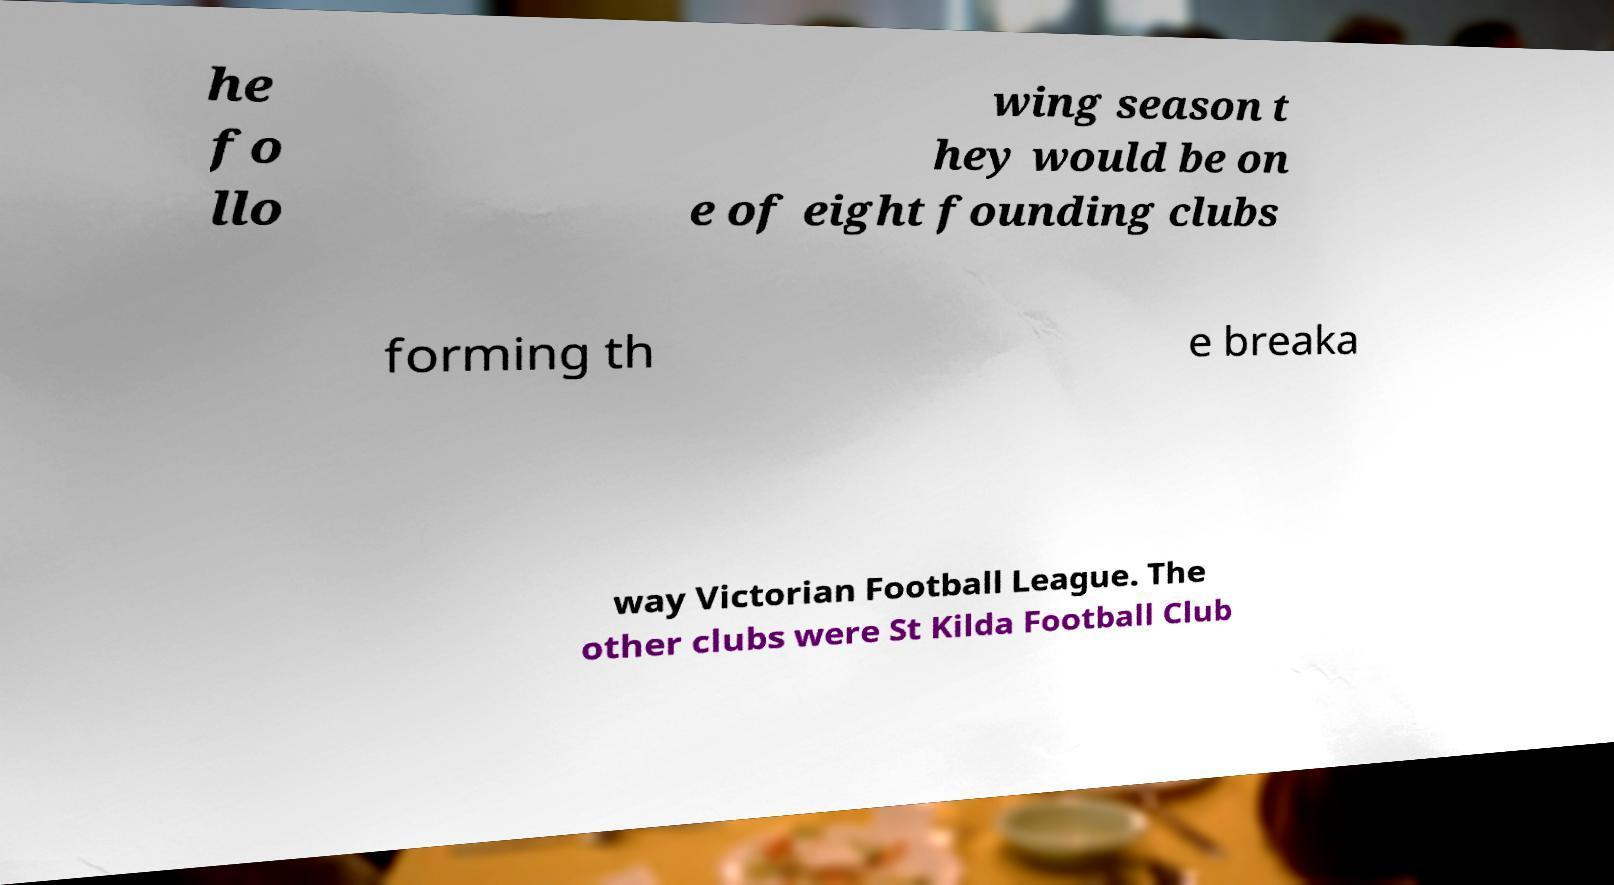Can you accurately transcribe the text from the provided image for me? he fo llo wing season t hey would be on e of eight founding clubs forming th e breaka way Victorian Football League. The other clubs were St Kilda Football Club 